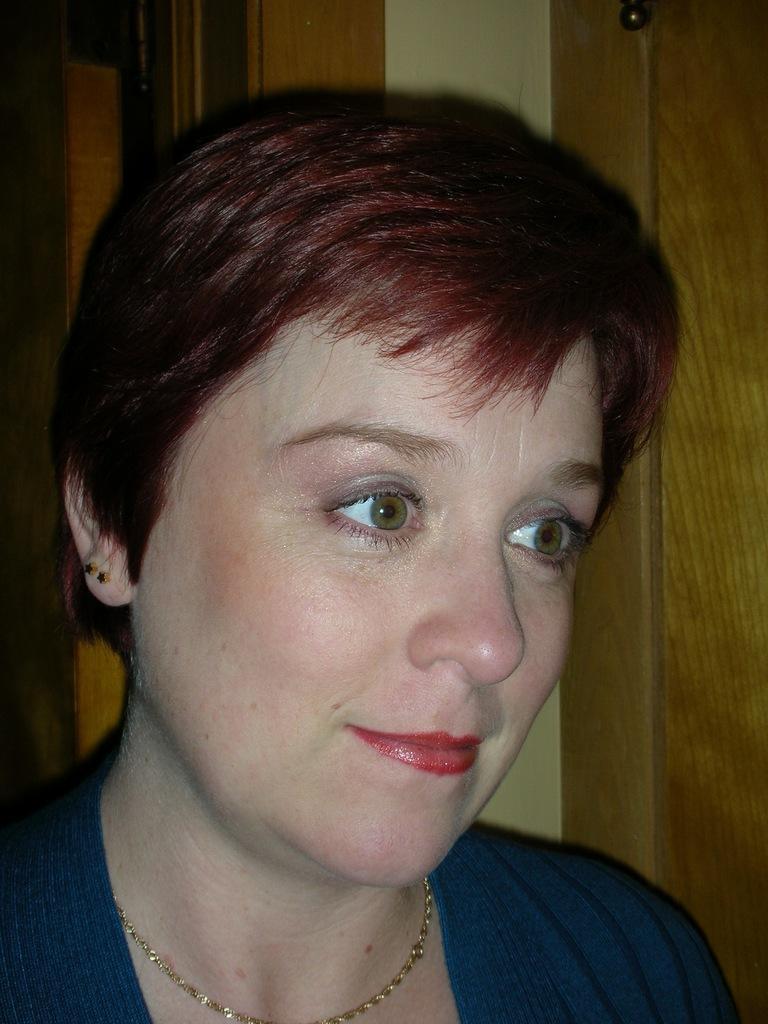Describe this image in one or two sentences. In this picture we can see a woman and other objects in the background. 